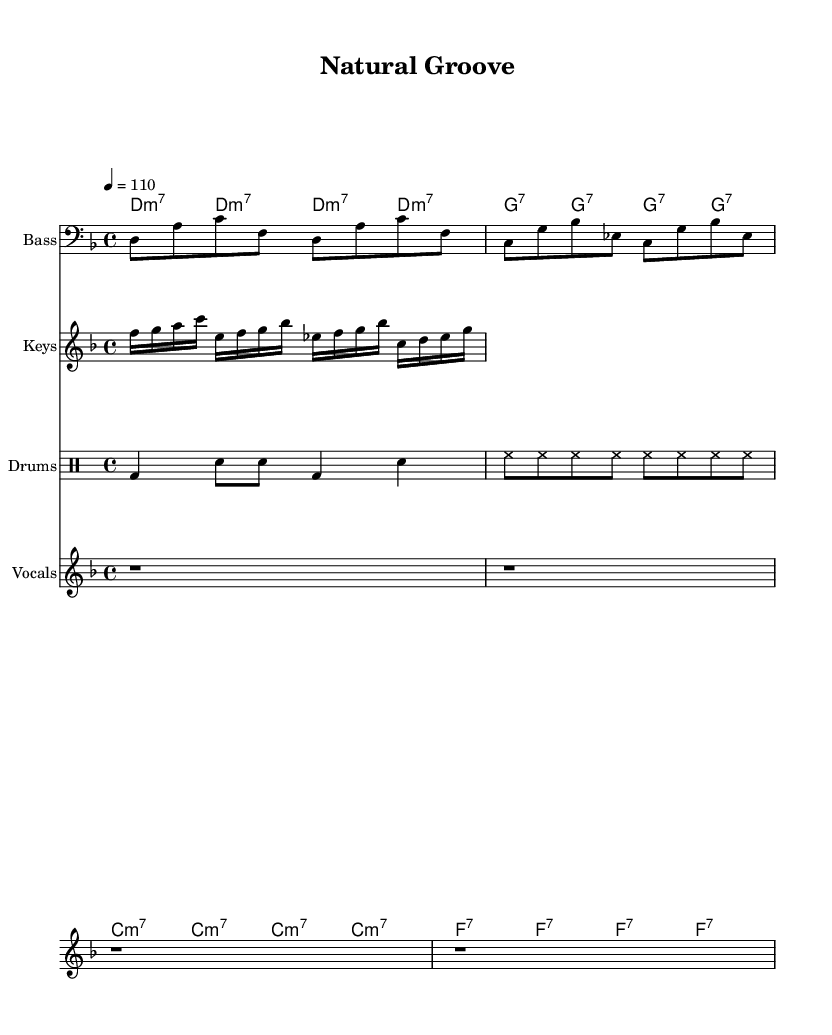What is the key signature of this music? The key signature is D minor, as indicated by the presence of one flat (B flat) in the key signature located at the beginning of the staff.
Answer: D minor What is the time signature of this music? The time signature is 4/4, which is displayed at the beginning of the score indicating that there are four beats per measure, and the quarter note gets one beat.
Answer: 4/4 What is the tempo marking? The tempo is marked at 110 beats per minute, indicated by the tempo text "4 = 110," which specifies how fast the piece should be played.
Answer: 110 How many measures are in the verse section? The verse section consists of four measures, which can be counted by visually viewing the bar lines in the score separating each measure.
Answer: 4 Which instrument has the bass line? The bass line is played by the instrument labeled "Bass," as indicated above the staff specifically notated for that line of music.
Answer: Bass What type of chords are used in the chorus? The chords in the chorus are predominantly seventh chords, as all chords shown are in the seventh format, such as G7 and F7.
Answer: Seventh chords What musical genre does this piece represent? The overall characteristics, such as syncopated rhythms and lyrical themes, clearly identify the piece as belonging to the Funk genre.
Answer: Funk 